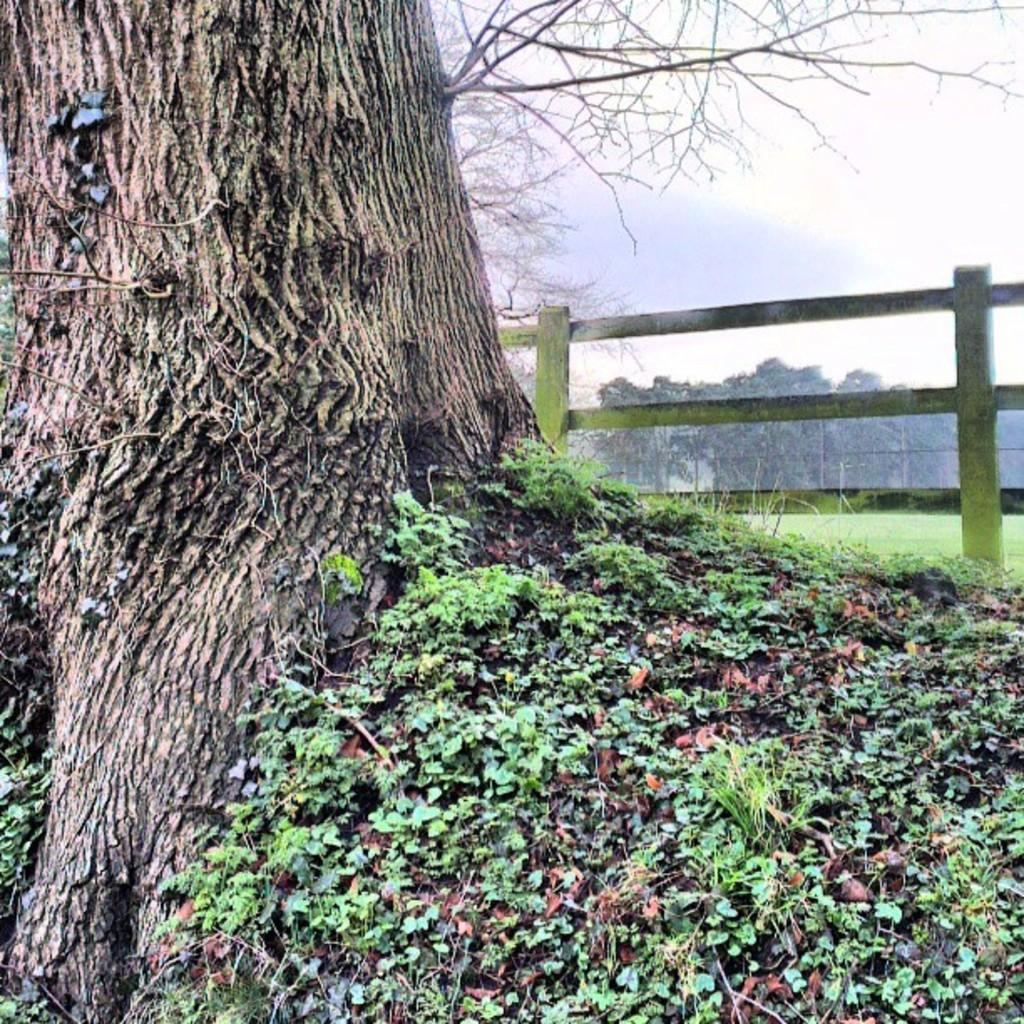What type of vegetation can be seen in the image? There is grass in the image. What part of a tree is visible in the image? The trunk of a tree is visible in the image. What type of fencing is present in the image? There is wooden fencing in the image. What can be seen in the background of the image? There are trees in the background of the image. What is visible at the top of the image? The sky is clear and visible at the top of the image. What type of relation does the needle have with the wooden fencing in the image? There is no needle present in the image, so it cannot have any relation with the wooden fencing. 